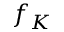<formula> <loc_0><loc_0><loc_500><loc_500>f _ { K }</formula> 